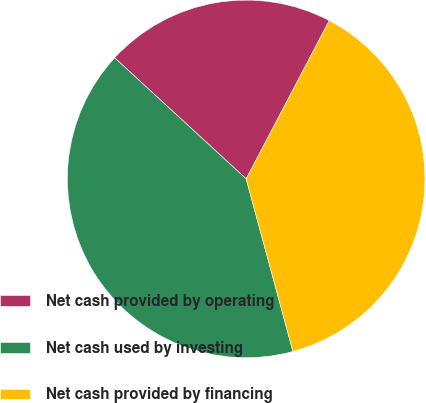<chart> <loc_0><loc_0><loc_500><loc_500><pie_chart><fcel>Net cash provided by operating<fcel>Net cash used by investing<fcel>Net cash provided by financing<nl><fcel>20.85%<fcel>41.05%<fcel>38.09%<nl></chart> 